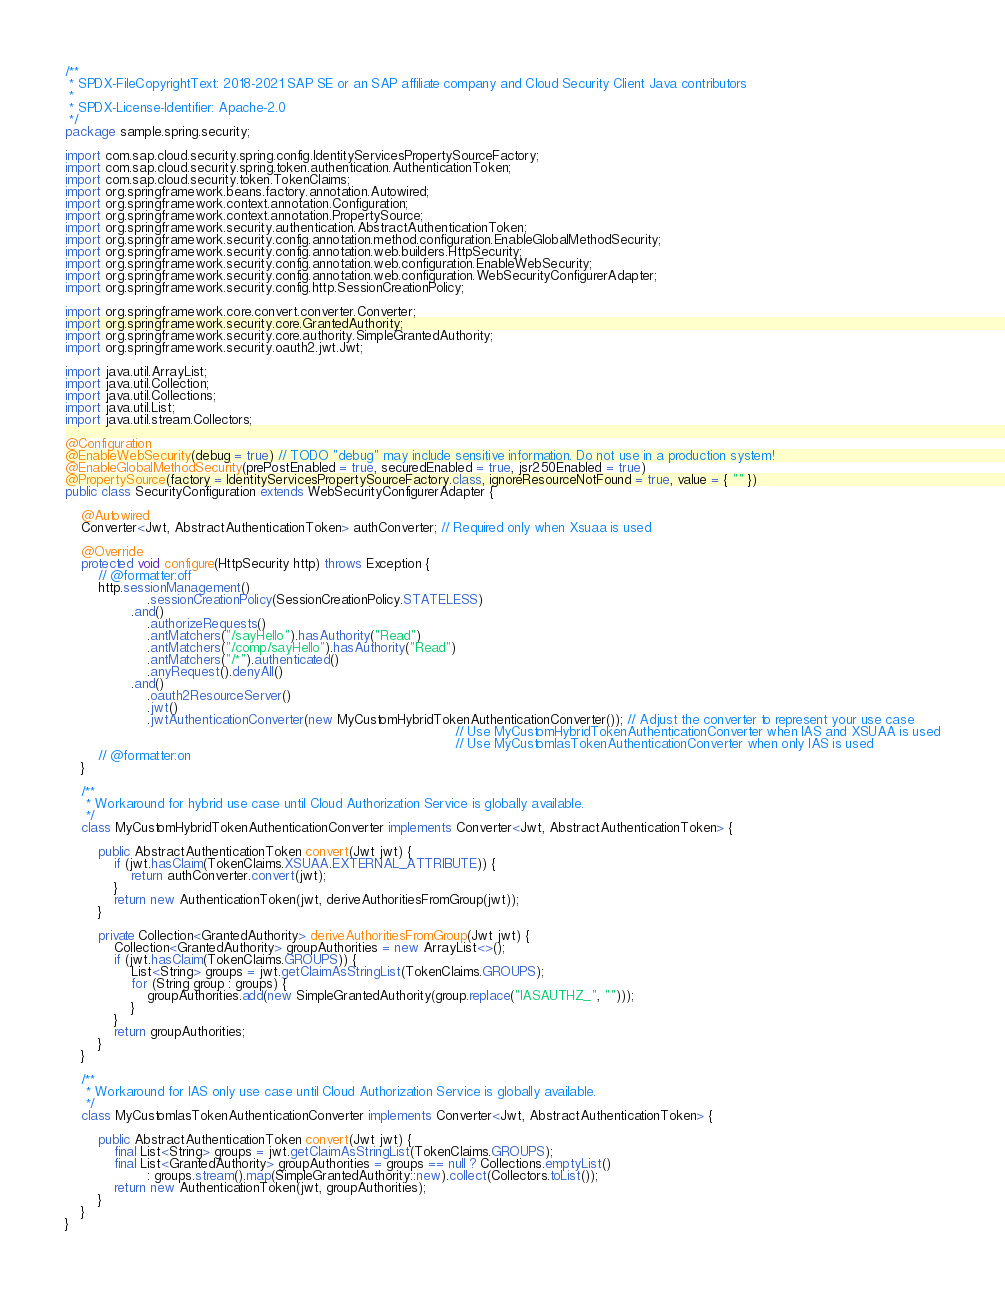<code> <loc_0><loc_0><loc_500><loc_500><_Java_>/**
 * SPDX-FileCopyrightText: 2018-2021 SAP SE or an SAP affiliate company and Cloud Security Client Java contributors
 *
 * SPDX-License-Identifier: Apache-2.0
 */
package sample.spring.security;

import com.sap.cloud.security.spring.config.IdentityServicesPropertySourceFactory;
import com.sap.cloud.security.spring.token.authentication.AuthenticationToken;
import com.sap.cloud.security.token.TokenClaims;
import org.springframework.beans.factory.annotation.Autowired;
import org.springframework.context.annotation.Configuration;
import org.springframework.context.annotation.PropertySource;
import org.springframework.security.authentication.AbstractAuthenticationToken;
import org.springframework.security.config.annotation.method.configuration.EnableGlobalMethodSecurity;
import org.springframework.security.config.annotation.web.builders.HttpSecurity;
import org.springframework.security.config.annotation.web.configuration.EnableWebSecurity;
import org.springframework.security.config.annotation.web.configuration.WebSecurityConfigurerAdapter;
import org.springframework.security.config.http.SessionCreationPolicy;

import org.springframework.core.convert.converter.Converter;
import org.springframework.security.core.GrantedAuthority;
import org.springframework.security.core.authority.SimpleGrantedAuthority;
import org.springframework.security.oauth2.jwt.Jwt;

import java.util.ArrayList;
import java.util.Collection;
import java.util.Collections;
import java.util.List;
import java.util.stream.Collectors;

@Configuration
@EnableWebSecurity(debug = true) // TODO "debug" may include sensitive information. Do not use in a production system!
@EnableGlobalMethodSecurity(prePostEnabled = true, securedEnabled = true, jsr250Enabled = true)
@PropertySource(factory = IdentityServicesPropertySourceFactory.class, ignoreResourceNotFound = true, value = { "" })
public class SecurityConfiguration extends WebSecurityConfigurerAdapter {

    @Autowired
    Converter<Jwt, AbstractAuthenticationToken> authConverter; // Required only when Xsuaa is used

    @Override
    protected void configure(HttpSecurity http) throws Exception {
        // @formatter:off
        http.sessionManagement()
                    .sessionCreationPolicy(SessionCreationPolicy.STATELESS)
                .and()
                    .authorizeRequests()
                    .antMatchers("/sayHello").hasAuthority("Read")
                    .antMatchers("/comp/sayHello").hasAuthority("Read")
                    .antMatchers("/*").authenticated()
                    .anyRequest().denyAll()
                .and()
                    .oauth2ResourceServer()
                    .jwt()
                    .jwtAuthenticationConverter(new MyCustomHybridTokenAuthenticationConverter()); // Adjust the converter to represent your use case
                                                                                               // Use MyCustomHybridTokenAuthenticationConverter when IAS and XSUAA is used
                                                                                               // Use MyCustomIasTokenAuthenticationConverter when only IAS is used
        // @formatter:on
    }

    /**
     * Workaround for hybrid use case until Cloud Authorization Service is globally available.
     */
    class MyCustomHybridTokenAuthenticationConverter implements Converter<Jwt, AbstractAuthenticationToken> {

        public AbstractAuthenticationToken convert(Jwt jwt) {
            if (jwt.hasClaim(TokenClaims.XSUAA.EXTERNAL_ATTRIBUTE)) {
                return authConverter.convert(jwt);
            }
            return new AuthenticationToken(jwt, deriveAuthoritiesFromGroup(jwt));
        }

        private Collection<GrantedAuthority> deriveAuthoritiesFromGroup(Jwt jwt) {
            Collection<GrantedAuthority> groupAuthorities = new ArrayList<>();
            if (jwt.hasClaim(TokenClaims.GROUPS)) {
                List<String> groups = jwt.getClaimAsStringList(TokenClaims.GROUPS);
                for (String group : groups) {
                    groupAuthorities.add(new SimpleGrantedAuthority(group.replace("IASAUTHZ_", "")));
                }
            }
            return groupAuthorities;
        }
    }

    /**
     * Workaround for IAS only use case until Cloud Authorization Service is globally available.
     */
    class MyCustomIasTokenAuthenticationConverter implements Converter<Jwt, AbstractAuthenticationToken> {

        public AbstractAuthenticationToken convert(Jwt jwt) {
            final List<String> groups = jwt.getClaimAsStringList(TokenClaims.GROUPS);
            final List<GrantedAuthority> groupAuthorities = groups == null ? Collections.emptyList()
                    : groups.stream().map(SimpleGrantedAuthority::new).collect(Collectors.toList());
            return new AuthenticationToken(jwt, groupAuthorities);
        }
    }
}
</code> 